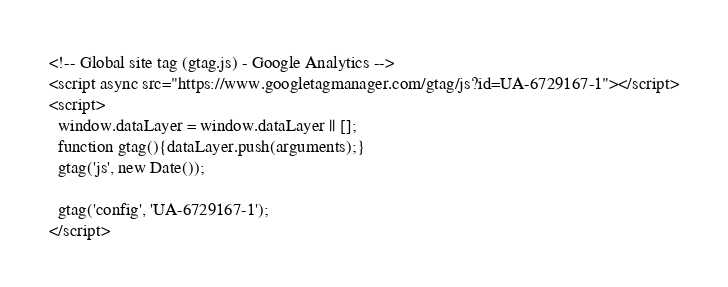Convert code to text. <code><loc_0><loc_0><loc_500><loc_500><_HTML_><!-- Global site tag (gtag.js) - Google Analytics -->
<script async src="https://www.googletagmanager.com/gtag/js?id=UA-6729167-1"></script>
<script>
  window.dataLayer = window.dataLayer || [];
  function gtag(){dataLayer.push(arguments);}
  gtag('js', new Date());

  gtag('config', 'UA-6729167-1');
</script>
</code> 